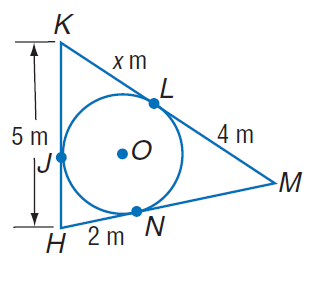Answer the mathemtical geometry problem and directly provide the correct option letter.
Question: Find x. Assume that segments that appear to be tangent are tangent.
Choices: A: 3 B: 4 C: 5 D: 6 A 